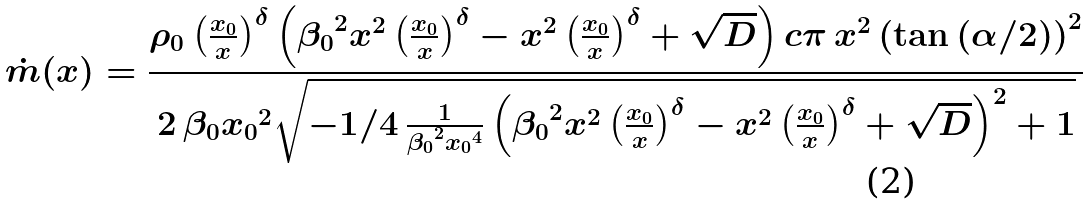<formula> <loc_0><loc_0><loc_500><loc_500>\dot { m } ( x ) = \frac { \rho _ { 0 } \left ( { \frac { x _ { 0 } } { x } } \right ) ^ { \delta } \left ( { \beta _ { 0 } } ^ { 2 } { x } ^ { 2 } \left ( { \frac { x _ { 0 } } { x } } \right ) ^ { \delta } - { x } ^ { 2 } \left ( { \frac { x _ { 0 } } { x } } \right ) ^ { \delta } + \sqrt { D } \right ) c \pi \, { x } ^ { 2 } \left ( \tan \left ( \alpha / 2 \right ) \right ) ^ { 2 } } { 2 \, \beta _ { 0 } { x _ { 0 } } ^ { 2 } \sqrt { - 1 / 4 \, { \frac { 1 } { { \beta _ { 0 } } ^ { 2 } { x _ { 0 } } ^ { 4 } } \left ( { \beta _ { 0 } } ^ { 2 } { x } ^ { 2 } \left ( { \frac { x _ { 0 } } { x } } \right ) ^ { \delta } - { x } ^ { 2 } \left ( { \frac { x _ { 0 } } { x } } \right ) ^ { \delta } + \sqrt { D } \right ) ^ { 2 } } + 1 } }</formula> 